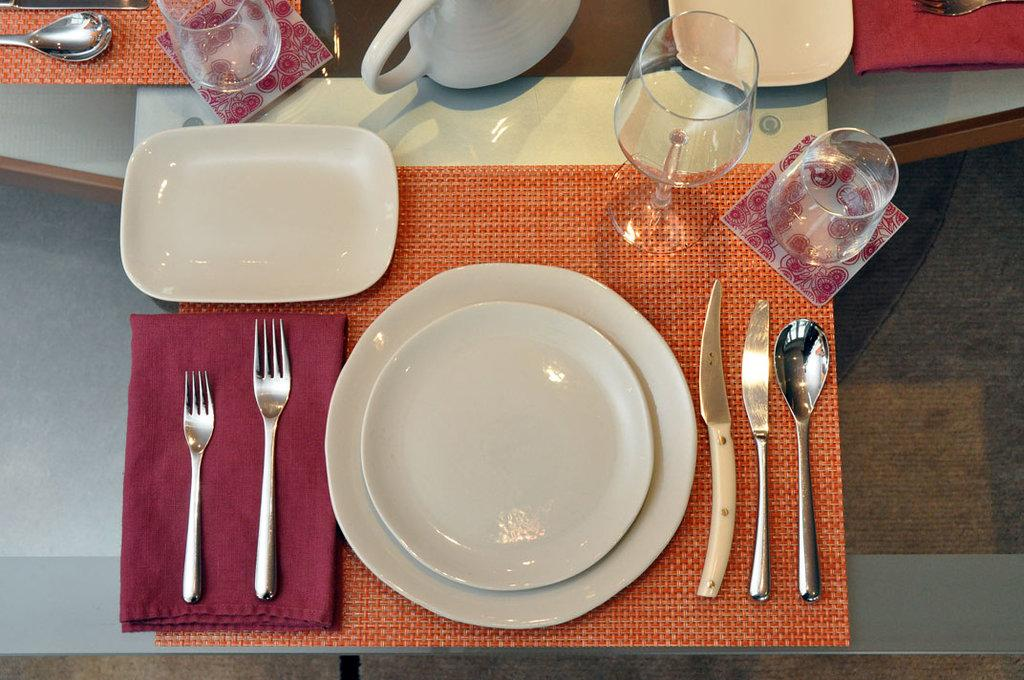What type of tableware can be seen on the table in the image? There are plates, forks, knives, spoons, glasses, and jugs on the table in the image. What might be used for cutting in the image? Knives can be used for cutting in the image. What might be used for drinking in the image? Glasses can be used for drinking in the image. What might be used for serving liquids in the image? Jugs can be used for serving liquids in the image. Can you see any toes on the table in the image? There are no toes present on the table in the image. What type of cave is visible in the image? There is no cave present in the image; it features a table with various types of tableware. 